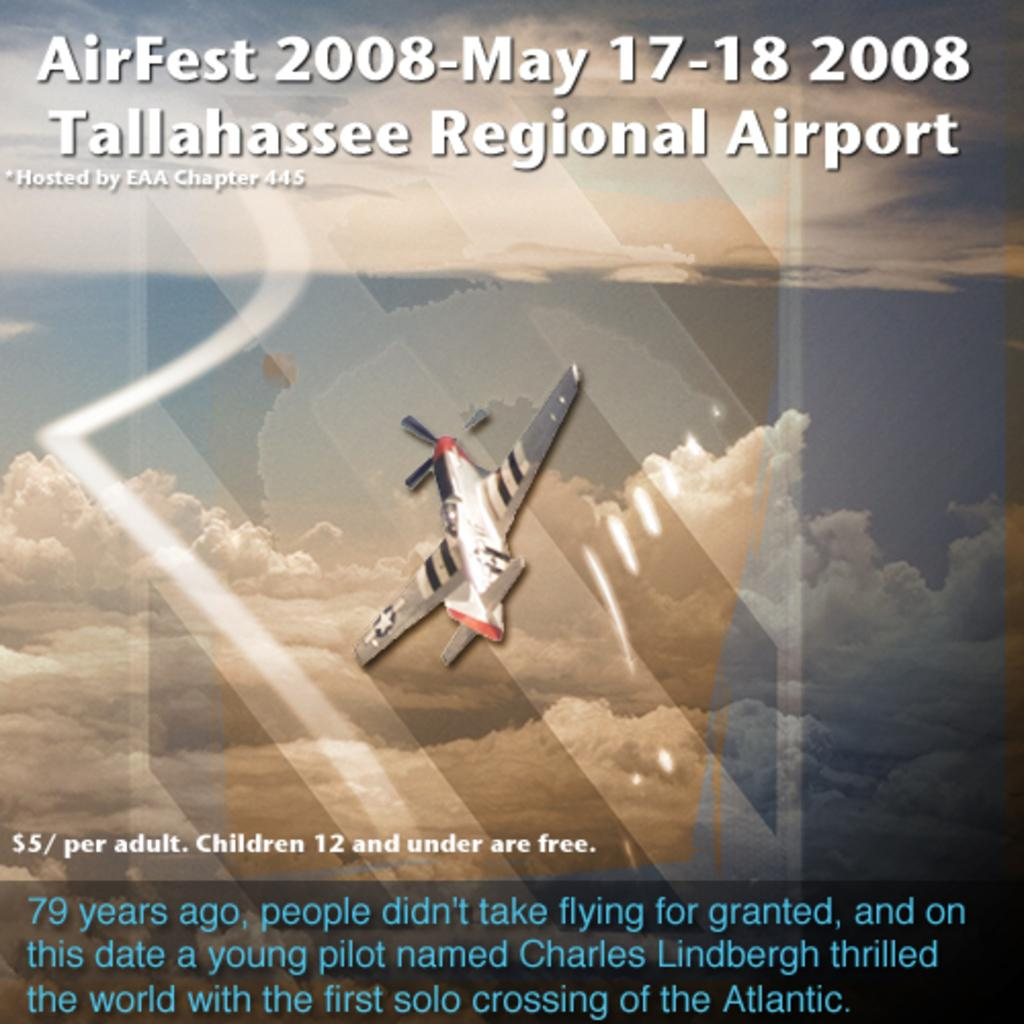What is the main subject of the image? The main subject of the image is an airplane. Where is the airplane located in the image? The airplane is in the air. What can be seen in the background of the image? There is sky visible in the background of the image. What is the condition of the sky in the image? Clouds are present in the sky. What is written on the image? There is text at the top and bottom of the image. Can you tell me how many mittens are being requested in the image? There are no mittens or requests present in the image; it features an airplane in the sky with text and clouds. What type of map is shown in the image? There is no map present in the image. 